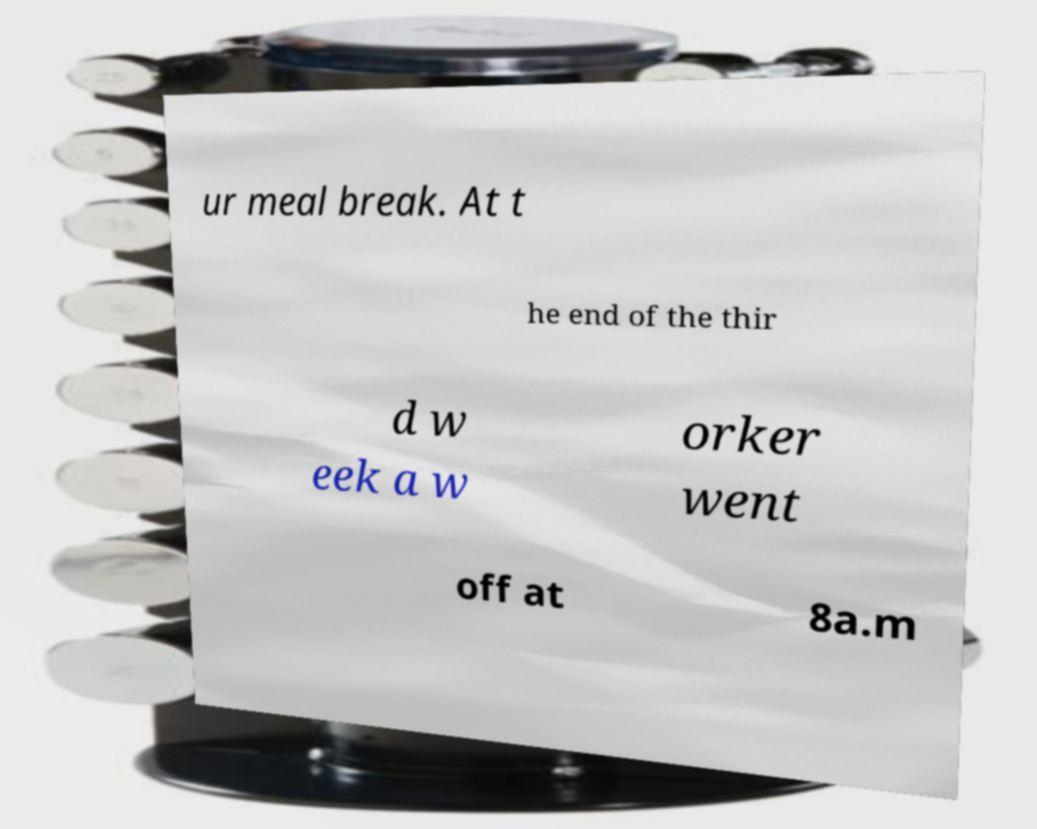I need the written content from this picture converted into text. Can you do that? ur meal break. At t he end of the thir d w eek a w orker went off at 8a.m 